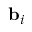<formula> <loc_0><loc_0><loc_500><loc_500>{ b } _ { i }</formula> 